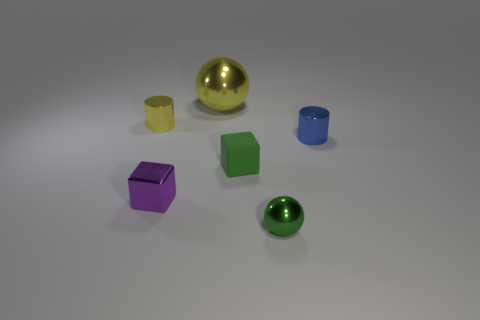What number of other small blue metallic objects are the same shape as the blue shiny object?
Keep it short and to the point. 0. Do the small rubber block and the tiny ball have the same color?
Provide a short and direct response. Yes. Is the number of metallic objects less than the number of large brown rubber spheres?
Your answer should be very brief. No. What is the cylinder in front of the yellow cylinder made of?
Your response must be concise. Metal. What material is the yellow cylinder that is the same size as the green shiny thing?
Keep it short and to the point. Metal. What is the material of the small cylinder behind the cylinder that is in front of the small cylinder that is left of the blue metallic object?
Give a very brief answer. Metal. There is a cylinder that is on the left side of the matte block; does it have the same size as the green matte block?
Ensure brevity in your answer.  Yes. Is the number of small green metal objects greater than the number of tiny shiny objects?
Provide a short and direct response. No. How many small objects are either green cubes or red things?
Provide a short and direct response. 1. What number of other objects are there of the same color as the tiny matte thing?
Offer a very short reply. 1. 